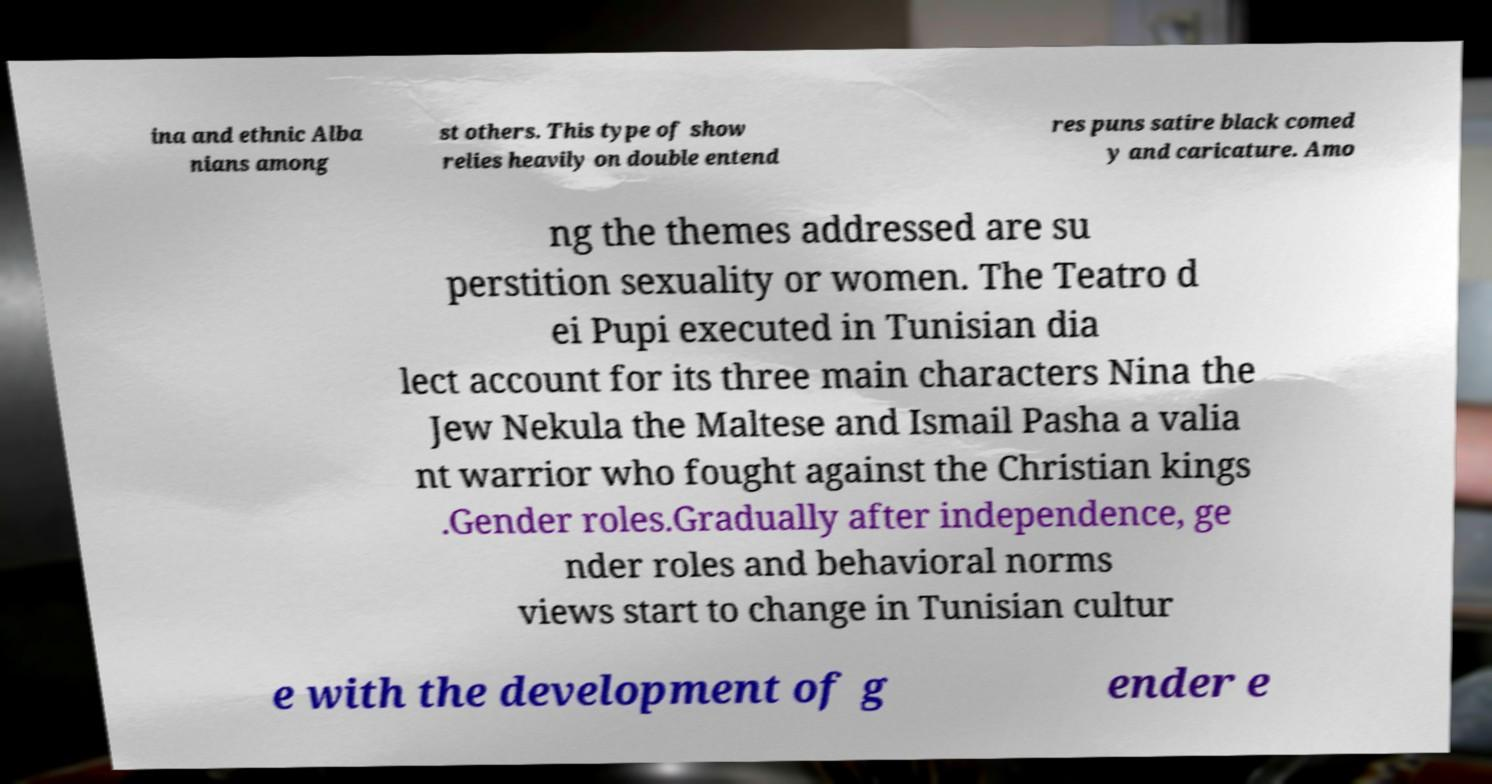There's text embedded in this image that I need extracted. Can you transcribe it verbatim? ina and ethnic Alba nians among st others. This type of show relies heavily on double entend res puns satire black comed y and caricature. Amo ng the themes addressed are su perstition sexuality or women. The Teatro d ei Pupi executed in Tunisian dia lect account for its three main characters Nina the Jew Nekula the Maltese and Ismail Pasha a valia nt warrior who fought against the Christian kings .Gender roles.Gradually after independence, ge nder roles and behavioral norms views start to change in Tunisian cultur e with the development of g ender e 